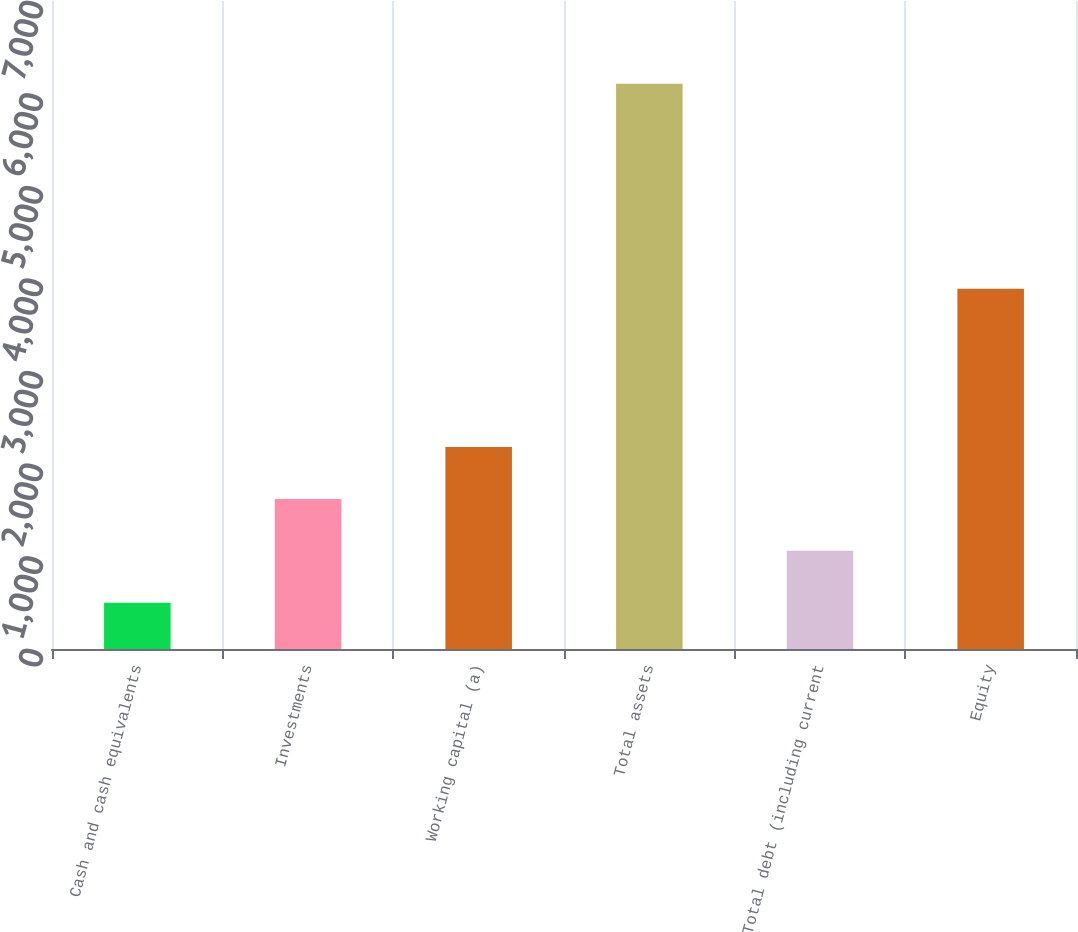Convert chart to OTSL. <chart><loc_0><loc_0><loc_500><loc_500><bar_chart><fcel>Cash and cash equivalents<fcel>Investments<fcel>Working capital (a)<fcel>Total assets<fcel>Total debt (including current<fcel>Equity<nl><fcel>499.7<fcel>1620.92<fcel>2181.53<fcel>6105.8<fcel>1060.31<fcel>3891.6<nl></chart> 